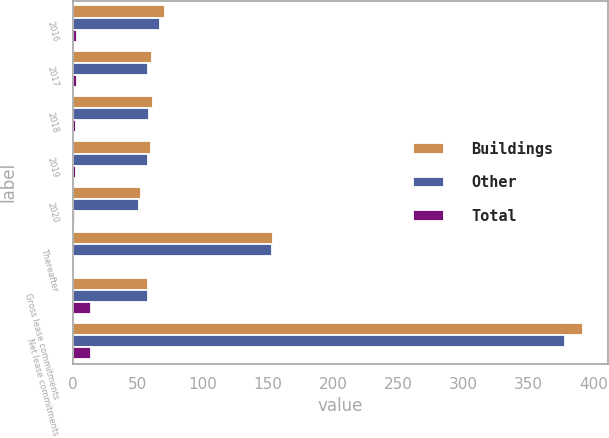Convert chart to OTSL. <chart><loc_0><loc_0><loc_500><loc_500><stacked_bar_chart><ecel><fcel>2016<fcel>2017<fcel>2018<fcel>2019<fcel>2020<fcel>Thereafter<fcel>Gross lease commitments<fcel>Net lease commitments<nl><fcel>Buildings<fcel>70.5<fcel>60.5<fcel>61.4<fcel>60.2<fcel>52.4<fcel>154<fcel>57.6<fcel>392<nl><fcel>Other<fcel>67.2<fcel>57.4<fcel>58.7<fcel>57.8<fcel>50.7<fcel>153.2<fcel>57.6<fcel>378<nl><fcel>Total<fcel>3.3<fcel>3.1<fcel>2.7<fcel>2.4<fcel>1.7<fcel>0.8<fcel>14<fcel>14<nl></chart> 